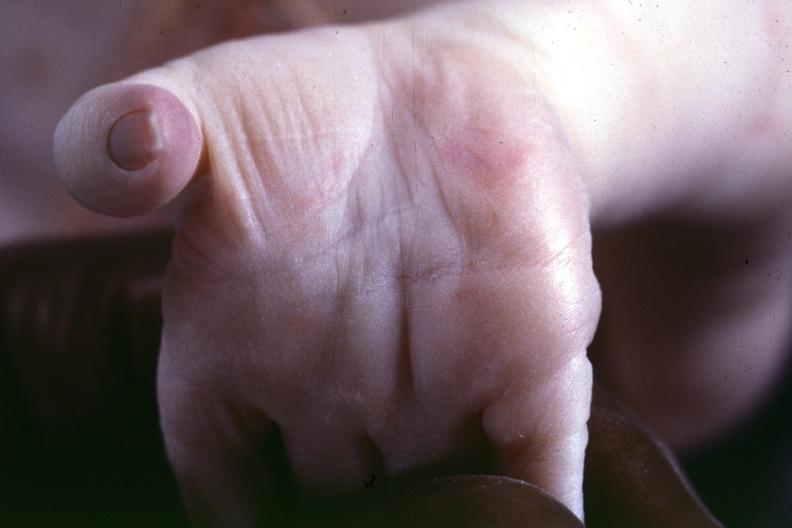how is previous slide from this case a crease suspect?
Answer the question using a single word or phrase. Simian 